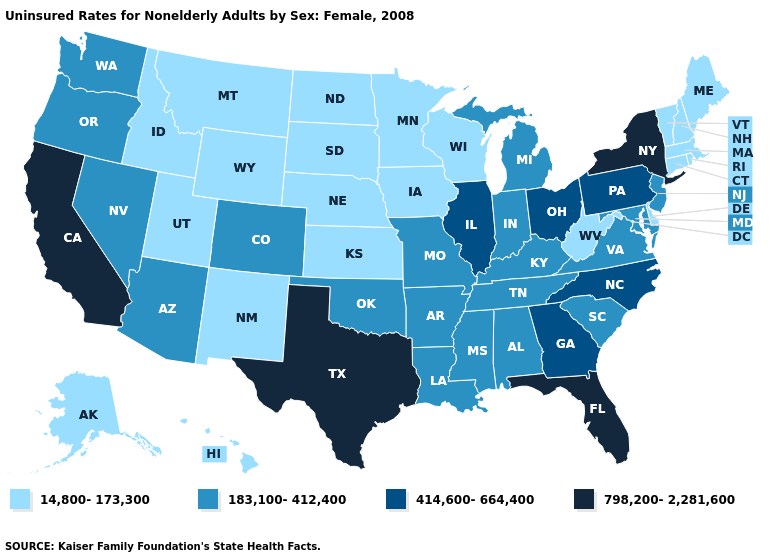Among the states that border Delaware , which have the highest value?
Give a very brief answer. Pennsylvania. Does the map have missing data?
Be succinct. No. Does North Carolina have the same value as Minnesota?
Concise answer only. No. What is the highest value in the USA?
Short answer required. 798,200-2,281,600. What is the value of New Mexico?
Keep it brief. 14,800-173,300. What is the value of Nebraska?
Answer briefly. 14,800-173,300. Which states have the highest value in the USA?
Concise answer only. California, Florida, New York, Texas. Does Louisiana have the lowest value in the USA?
Be succinct. No. What is the highest value in states that border New York?
Give a very brief answer. 414,600-664,400. Does Maryland have the highest value in the USA?
Give a very brief answer. No. Does Rhode Island have the highest value in the Northeast?
Keep it brief. No. Among the states that border Washington , which have the lowest value?
Give a very brief answer. Idaho. 